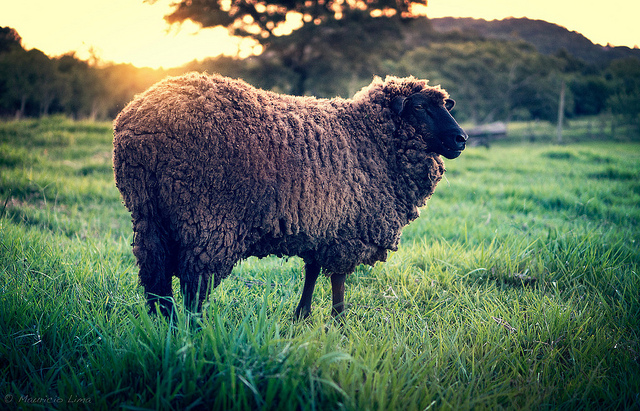If this image was part of a fantasy world, what would the sheep's role be? In a fantasy world, this sheep might be a guardian of an enchanted meadow. Its wool could possess magical properties that bring prosperity and peace to the land. The sheep might be cherished by the inhabitants of the realm, and legends would say that as long as the sheep roams freely, the land would be blessed with eternal harmony and beauty. 